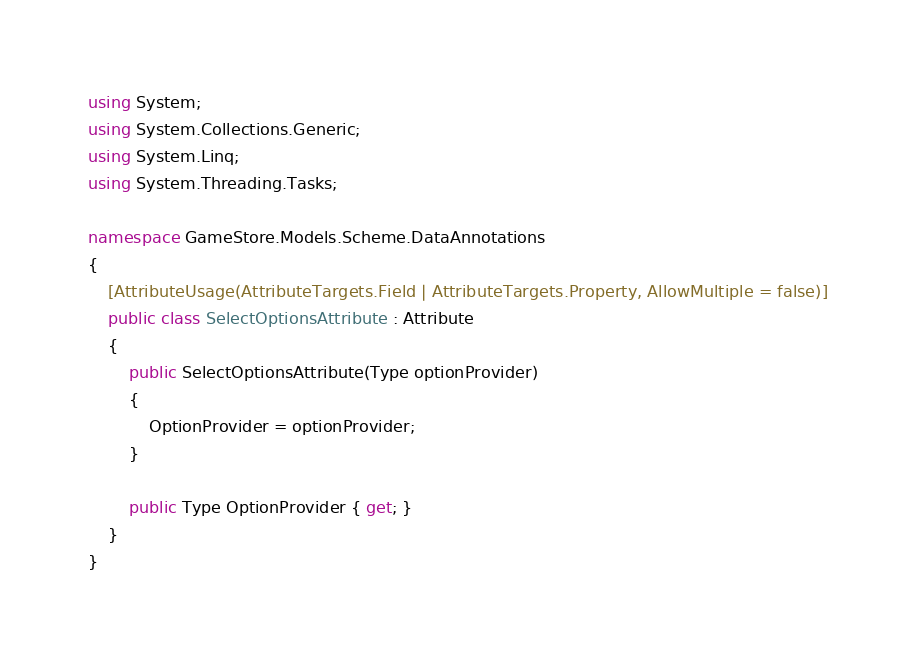<code> <loc_0><loc_0><loc_500><loc_500><_C#_>using System;
using System.Collections.Generic;
using System.Linq;
using System.Threading.Tasks;

namespace GameStore.Models.Scheme.DataAnnotations
{
    [AttributeUsage(AttributeTargets.Field | AttributeTargets.Property, AllowMultiple = false)]
    public class SelectOptionsAttribute : Attribute
    {
        public SelectOptionsAttribute(Type optionProvider)
        {
            OptionProvider = optionProvider;
        }

        public Type OptionProvider { get; }
    }
}
</code> 